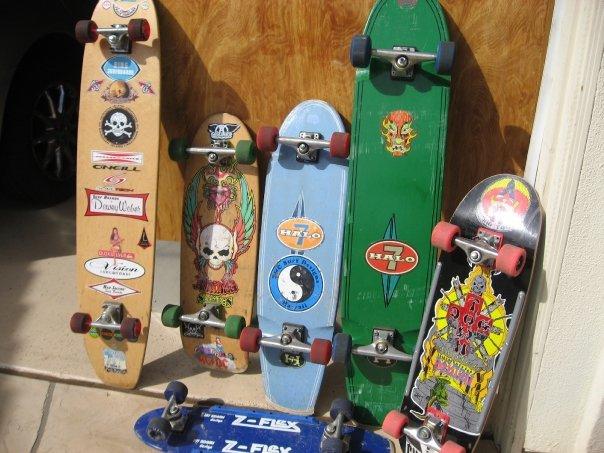Are there any red skateboards?
Short answer required. No. How many boards are shown?
Concise answer only. 6. How many skateboards are laying down?
Keep it brief. 1. Are the boards hanging in the air?
Give a very brief answer. No. What are the items shown?
Quick response, please. Skateboards. What position is the skateboards in?
Give a very brief answer. Upright. 